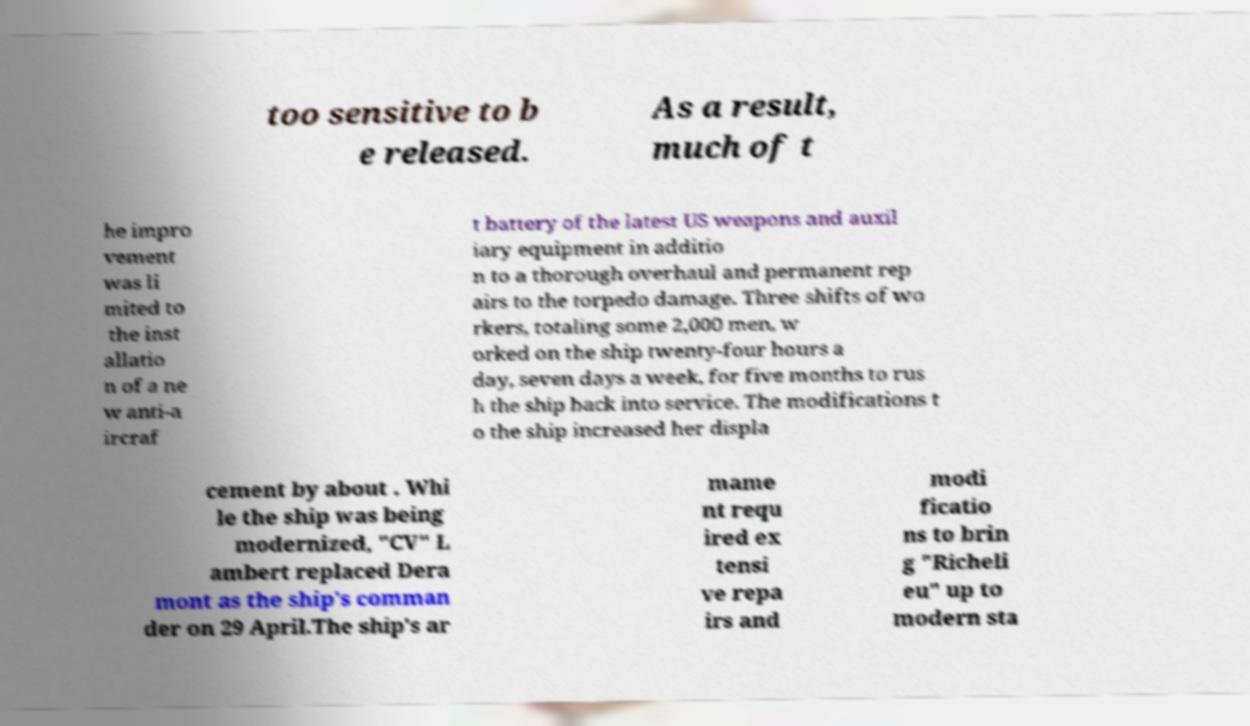Can you accurately transcribe the text from the provided image for me? too sensitive to b e released. As a result, much of t he impro vement was li mited to the inst allatio n of a ne w anti-a ircraf t battery of the latest US weapons and auxil iary equipment in additio n to a thorough overhaul and permanent rep airs to the torpedo damage. Three shifts of wo rkers, totaling some 2,000 men, w orked on the ship twenty-four hours a day, seven days a week, for five months to rus h the ship back into service. The modifications t o the ship increased her displa cement by about . Whi le the ship was being modernized, "CV" L ambert replaced Dera mont as the ship's comman der on 29 April.The ship's ar mame nt requ ired ex tensi ve repa irs and modi ficatio ns to brin g "Richeli eu" up to modern sta 